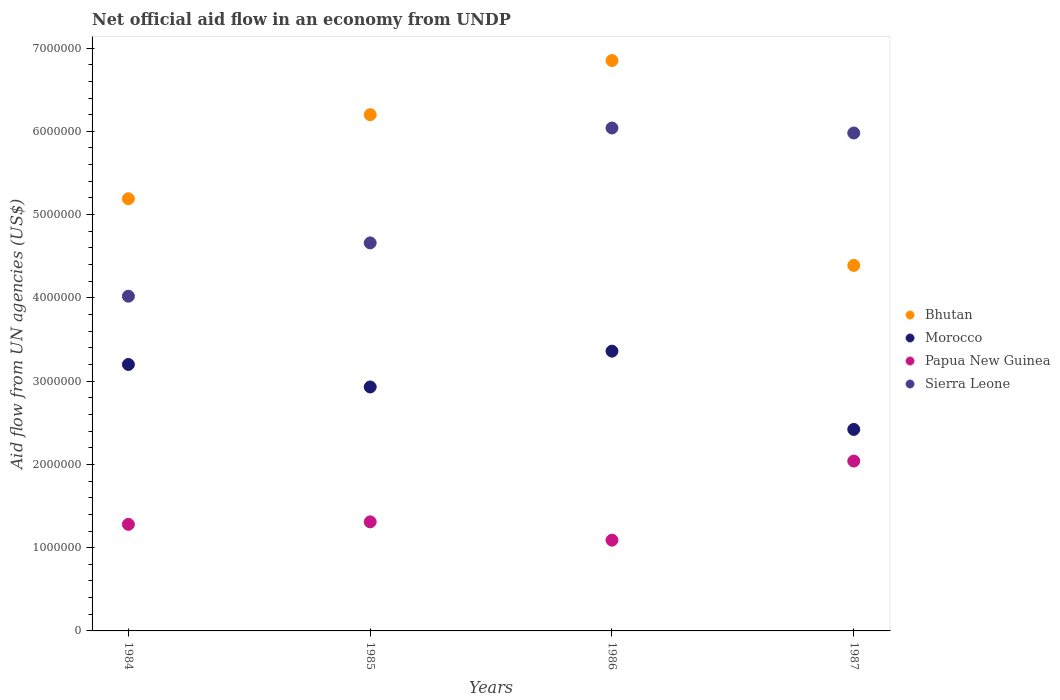Is the number of dotlines equal to the number of legend labels?
Your answer should be very brief. Yes. What is the net official aid flow in Sierra Leone in 1984?
Ensure brevity in your answer.  4.02e+06. Across all years, what is the maximum net official aid flow in Sierra Leone?
Give a very brief answer. 6.04e+06. Across all years, what is the minimum net official aid flow in Sierra Leone?
Give a very brief answer. 4.02e+06. In which year was the net official aid flow in Morocco maximum?
Your response must be concise. 1986. In which year was the net official aid flow in Papua New Guinea minimum?
Offer a terse response. 1986. What is the total net official aid flow in Sierra Leone in the graph?
Your answer should be compact. 2.07e+07. What is the difference between the net official aid flow in Papua New Guinea in 1984 and that in 1987?
Give a very brief answer. -7.60e+05. What is the difference between the net official aid flow in Papua New Guinea in 1985 and the net official aid flow in Bhutan in 1987?
Provide a short and direct response. -3.08e+06. What is the average net official aid flow in Bhutan per year?
Provide a short and direct response. 5.66e+06. In the year 1987, what is the difference between the net official aid flow in Morocco and net official aid flow in Papua New Guinea?
Keep it short and to the point. 3.80e+05. In how many years, is the net official aid flow in Bhutan greater than 1400000 US$?
Your answer should be compact. 4. What is the ratio of the net official aid flow in Morocco in 1985 to that in 1986?
Give a very brief answer. 0.87. Is the net official aid flow in Bhutan in 1984 less than that in 1987?
Make the answer very short. No. What is the difference between the highest and the lowest net official aid flow in Sierra Leone?
Ensure brevity in your answer.  2.02e+06. Is the sum of the net official aid flow in Papua New Guinea in 1985 and 1986 greater than the maximum net official aid flow in Morocco across all years?
Offer a very short reply. No. Is the net official aid flow in Morocco strictly less than the net official aid flow in Sierra Leone over the years?
Provide a succinct answer. Yes. Does the graph contain any zero values?
Offer a terse response. No. Where does the legend appear in the graph?
Provide a succinct answer. Center right. How many legend labels are there?
Offer a terse response. 4. What is the title of the graph?
Provide a succinct answer. Net official aid flow in an economy from UNDP. What is the label or title of the Y-axis?
Provide a short and direct response. Aid flow from UN agencies (US$). What is the Aid flow from UN agencies (US$) of Bhutan in 1984?
Make the answer very short. 5.19e+06. What is the Aid flow from UN agencies (US$) of Morocco in 1984?
Make the answer very short. 3.20e+06. What is the Aid flow from UN agencies (US$) of Papua New Guinea in 1984?
Your response must be concise. 1.28e+06. What is the Aid flow from UN agencies (US$) in Sierra Leone in 1984?
Your answer should be very brief. 4.02e+06. What is the Aid flow from UN agencies (US$) in Bhutan in 1985?
Offer a very short reply. 6.20e+06. What is the Aid flow from UN agencies (US$) of Morocco in 1985?
Your answer should be very brief. 2.93e+06. What is the Aid flow from UN agencies (US$) in Papua New Guinea in 1985?
Your answer should be very brief. 1.31e+06. What is the Aid flow from UN agencies (US$) in Sierra Leone in 1985?
Make the answer very short. 4.66e+06. What is the Aid flow from UN agencies (US$) in Bhutan in 1986?
Ensure brevity in your answer.  6.85e+06. What is the Aid flow from UN agencies (US$) of Morocco in 1986?
Provide a short and direct response. 3.36e+06. What is the Aid flow from UN agencies (US$) in Papua New Guinea in 1986?
Give a very brief answer. 1.09e+06. What is the Aid flow from UN agencies (US$) of Sierra Leone in 1986?
Offer a terse response. 6.04e+06. What is the Aid flow from UN agencies (US$) of Bhutan in 1987?
Offer a terse response. 4.39e+06. What is the Aid flow from UN agencies (US$) in Morocco in 1987?
Give a very brief answer. 2.42e+06. What is the Aid flow from UN agencies (US$) of Papua New Guinea in 1987?
Ensure brevity in your answer.  2.04e+06. What is the Aid flow from UN agencies (US$) in Sierra Leone in 1987?
Your response must be concise. 5.98e+06. Across all years, what is the maximum Aid flow from UN agencies (US$) in Bhutan?
Keep it short and to the point. 6.85e+06. Across all years, what is the maximum Aid flow from UN agencies (US$) of Morocco?
Offer a terse response. 3.36e+06. Across all years, what is the maximum Aid flow from UN agencies (US$) of Papua New Guinea?
Offer a very short reply. 2.04e+06. Across all years, what is the maximum Aid flow from UN agencies (US$) of Sierra Leone?
Provide a short and direct response. 6.04e+06. Across all years, what is the minimum Aid flow from UN agencies (US$) in Bhutan?
Offer a very short reply. 4.39e+06. Across all years, what is the minimum Aid flow from UN agencies (US$) of Morocco?
Provide a short and direct response. 2.42e+06. Across all years, what is the minimum Aid flow from UN agencies (US$) of Papua New Guinea?
Offer a very short reply. 1.09e+06. Across all years, what is the minimum Aid flow from UN agencies (US$) in Sierra Leone?
Provide a succinct answer. 4.02e+06. What is the total Aid flow from UN agencies (US$) of Bhutan in the graph?
Give a very brief answer. 2.26e+07. What is the total Aid flow from UN agencies (US$) of Morocco in the graph?
Ensure brevity in your answer.  1.19e+07. What is the total Aid flow from UN agencies (US$) of Papua New Guinea in the graph?
Your answer should be compact. 5.72e+06. What is the total Aid flow from UN agencies (US$) in Sierra Leone in the graph?
Your answer should be very brief. 2.07e+07. What is the difference between the Aid flow from UN agencies (US$) of Bhutan in 1984 and that in 1985?
Your response must be concise. -1.01e+06. What is the difference between the Aid flow from UN agencies (US$) of Morocco in 1984 and that in 1985?
Make the answer very short. 2.70e+05. What is the difference between the Aid flow from UN agencies (US$) in Sierra Leone in 1984 and that in 1985?
Keep it short and to the point. -6.40e+05. What is the difference between the Aid flow from UN agencies (US$) in Bhutan in 1984 and that in 1986?
Make the answer very short. -1.66e+06. What is the difference between the Aid flow from UN agencies (US$) in Sierra Leone in 1984 and that in 1986?
Make the answer very short. -2.02e+06. What is the difference between the Aid flow from UN agencies (US$) in Morocco in 1984 and that in 1987?
Your answer should be compact. 7.80e+05. What is the difference between the Aid flow from UN agencies (US$) of Papua New Guinea in 1984 and that in 1987?
Offer a terse response. -7.60e+05. What is the difference between the Aid flow from UN agencies (US$) in Sierra Leone in 1984 and that in 1987?
Offer a very short reply. -1.96e+06. What is the difference between the Aid flow from UN agencies (US$) in Bhutan in 1985 and that in 1986?
Offer a very short reply. -6.50e+05. What is the difference between the Aid flow from UN agencies (US$) of Morocco in 1985 and that in 1986?
Provide a short and direct response. -4.30e+05. What is the difference between the Aid flow from UN agencies (US$) of Papua New Guinea in 1985 and that in 1986?
Your answer should be compact. 2.20e+05. What is the difference between the Aid flow from UN agencies (US$) in Sierra Leone in 1985 and that in 1986?
Your answer should be compact. -1.38e+06. What is the difference between the Aid flow from UN agencies (US$) of Bhutan in 1985 and that in 1987?
Keep it short and to the point. 1.81e+06. What is the difference between the Aid flow from UN agencies (US$) in Morocco in 1985 and that in 1987?
Make the answer very short. 5.10e+05. What is the difference between the Aid flow from UN agencies (US$) in Papua New Guinea in 1985 and that in 1987?
Your answer should be very brief. -7.30e+05. What is the difference between the Aid flow from UN agencies (US$) in Sierra Leone in 1985 and that in 1987?
Ensure brevity in your answer.  -1.32e+06. What is the difference between the Aid flow from UN agencies (US$) in Bhutan in 1986 and that in 1987?
Make the answer very short. 2.46e+06. What is the difference between the Aid flow from UN agencies (US$) in Morocco in 1986 and that in 1987?
Provide a short and direct response. 9.40e+05. What is the difference between the Aid flow from UN agencies (US$) in Papua New Guinea in 1986 and that in 1987?
Your response must be concise. -9.50e+05. What is the difference between the Aid flow from UN agencies (US$) of Bhutan in 1984 and the Aid flow from UN agencies (US$) of Morocco in 1985?
Your response must be concise. 2.26e+06. What is the difference between the Aid flow from UN agencies (US$) of Bhutan in 1984 and the Aid flow from UN agencies (US$) of Papua New Guinea in 1985?
Provide a short and direct response. 3.88e+06. What is the difference between the Aid flow from UN agencies (US$) of Bhutan in 1984 and the Aid flow from UN agencies (US$) of Sierra Leone in 1985?
Offer a terse response. 5.30e+05. What is the difference between the Aid flow from UN agencies (US$) of Morocco in 1984 and the Aid flow from UN agencies (US$) of Papua New Guinea in 1985?
Your answer should be compact. 1.89e+06. What is the difference between the Aid flow from UN agencies (US$) in Morocco in 1984 and the Aid flow from UN agencies (US$) in Sierra Leone in 1985?
Provide a short and direct response. -1.46e+06. What is the difference between the Aid flow from UN agencies (US$) of Papua New Guinea in 1984 and the Aid flow from UN agencies (US$) of Sierra Leone in 1985?
Provide a short and direct response. -3.38e+06. What is the difference between the Aid flow from UN agencies (US$) in Bhutan in 1984 and the Aid flow from UN agencies (US$) in Morocco in 1986?
Provide a short and direct response. 1.83e+06. What is the difference between the Aid flow from UN agencies (US$) of Bhutan in 1984 and the Aid flow from UN agencies (US$) of Papua New Guinea in 1986?
Offer a terse response. 4.10e+06. What is the difference between the Aid flow from UN agencies (US$) in Bhutan in 1984 and the Aid flow from UN agencies (US$) in Sierra Leone in 1986?
Offer a very short reply. -8.50e+05. What is the difference between the Aid flow from UN agencies (US$) in Morocco in 1984 and the Aid flow from UN agencies (US$) in Papua New Guinea in 1986?
Ensure brevity in your answer.  2.11e+06. What is the difference between the Aid flow from UN agencies (US$) of Morocco in 1984 and the Aid flow from UN agencies (US$) of Sierra Leone in 1986?
Provide a succinct answer. -2.84e+06. What is the difference between the Aid flow from UN agencies (US$) in Papua New Guinea in 1984 and the Aid flow from UN agencies (US$) in Sierra Leone in 1986?
Provide a succinct answer. -4.76e+06. What is the difference between the Aid flow from UN agencies (US$) in Bhutan in 1984 and the Aid flow from UN agencies (US$) in Morocco in 1987?
Keep it short and to the point. 2.77e+06. What is the difference between the Aid flow from UN agencies (US$) in Bhutan in 1984 and the Aid flow from UN agencies (US$) in Papua New Guinea in 1987?
Provide a short and direct response. 3.15e+06. What is the difference between the Aid flow from UN agencies (US$) in Bhutan in 1984 and the Aid flow from UN agencies (US$) in Sierra Leone in 1987?
Your answer should be very brief. -7.90e+05. What is the difference between the Aid flow from UN agencies (US$) in Morocco in 1984 and the Aid flow from UN agencies (US$) in Papua New Guinea in 1987?
Your response must be concise. 1.16e+06. What is the difference between the Aid flow from UN agencies (US$) in Morocco in 1984 and the Aid flow from UN agencies (US$) in Sierra Leone in 1987?
Offer a very short reply. -2.78e+06. What is the difference between the Aid flow from UN agencies (US$) in Papua New Guinea in 1984 and the Aid flow from UN agencies (US$) in Sierra Leone in 1987?
Offer a terse response. -4.70e+06. What is the difference between the Aid flow from UN agencies (US$) in Bhutan in 1985 and the Aid flow from UN agencies (US$) in Morocco in 1986?
Keep it short and to the point. 2.84e+06. What is the difference between the Aid flow from UN agencies (US$) of Bhutan in 1985 and the Aid flow from UN agencies (US$) of Papua New Guinea in 1986?
Make the answer very short. 5.11e+06. What is the difference between the Aid flow from UN agencies (US$) in Morocco in 1985 and the Aid flow from UN agencies (US$) in Papua New Guinea in 1986?
Keep it short and to the point. 1.84e+06. What is the difference between the Aid flow from UN agencies (US$) in Morocco in 1985 and the Aid flow from UN agencies (US$) in Sierra Leone in 1986?
Give a very brief answer. -3.11e+06. What is the difference between the Aid flow from UN agencies (US$) of Papua New Guinea in 1985 and the Aid flow from UN agencies (US$) of Sierra Leone in 1986?
Your response must be concise. -4.73e+06. What is the difference between the Aid flow from UN agencies (US$) in Bhutan in 1985 and the Aid flow from UN agencies (US$) in Morocco in 1987?
Provide a short and direct response. 3.78e+06. What is the difference between the Aid flow from UN agencies (US$) in Bhutan in 1985 and the Aid flow from UN agencies (US$) in Papua New Guinea in 1987?
Keep it short and to the point. 4.16e+06. What is the difference between the Aid flow from UN agencies (US$) in Bhutan in 1985 and the Aid flow from UN agencies (US$) in Sierra Leone in 1987?
Your answer should be compact. 2.20e+05. What is the difference between the Aid flow from UN agencies (US$) of Morocco in 1985 and the Aid flow from UN agencies (US$) of Papua New Guinea in 1987?
Your response must be concise. 8.90e+05. What is the difference between the Aid flow from UN agencies (US$) of Morocco in 1985 and the Aid flow from UN agencies (US$) of Sierra Leone in 1987?
Provide a short and direct response. -3.05e+06. What is the difference between the Aid flow from UN agencies (US$) in Papua New Guinea in 1985 and the Aid flow from UN agencies (US$) in Sierra Leone in 1987?
Offer a terse response. -4.67e+06. What is the difference between the Aid flow from UN agencies (US$) in Bhutan in 1986 and the Aid flow from UN agencies (US$) in Morocco in 1987?
Provide a succinct answer. 4.43e+06. What is the difference between the Aid flow from UN agencies (US$) of Bhutan in 1986 and the Aid flow from UN agencies (US$) of Papua New Guinea in 1987?
Your response must be concise. 4.81e+06. What is the difference between the Aid flow from UN agencies (US$) in Bhutan in 1986 and the Aid flow from UN agencies (US$) in Sierra Leone in 1987?
Your answer should be compact. 8.70e+05. What is the difference between the Aid flow from UN agencies (US$) in Morocco in 1986 and the Aid flow from UN agencies (US$) in Papua New Guinea in 1987?
Provide a short and direct response. 1.32e+06. What is the difference between the Aid flow from UN agencies (US$) in Morocco in 1986 and the Aid flow from UN agencies (US$) in Sierra Leone in 1987?
Your response must be concise. -2.62e+06. What is the difference between the Aid flow from UN agencies (US$) in Papua New Guinea in 1986 and the Aid flow from UN agencies (US$) in Sierra Leone in 1987?
Ensure brevity in your answer.  -4.89e+06. What is the average Aid flow from UN agencies (US$) in Bhutan per year?
Provide a succinct answer. 5.66e+06. What is the average Aid flow from UN agencies (US$) in Morocco per year?
Ensure brevity in your answer.  2.98e+06. What is the average Aid flow from UN agencies (US$) in Papua New Guinea per year?
Provide a succinct answer. 1.43e+06. What is the average Aid flow from UN agencies (US$) in Sierra Leone per year?
Ensure brevity in your answer.  5.18e+06. In the year 1984, what is the difference between the Aid flow from UN agencies (US$) in Bhutan and Aid flow from UN agencies (US$) in Morocco?
Provide a short and direct response. 1.99e+06. In the year 1984, what is the difference between the Aid flow from UN agencies (US$) of Bhutan and Aid flow from UN agencies (US$) of Papua New Guinea?
Make the answer very short. 3.91e+06. In the year 1984, what is the difference between the Aid flow from UN agencies (US$) of Bhutan and Aid flow from UN agencies (US$) of Sierra Leone?
Ensure brevity in your answer.  1.17e+06. In the year 1984, what is the difference between the Aid flow from UN agencies (US$) of Morocco and Aid flow from UN agencies (US$) of Papua New Guinea?
Your answer should be compact. 1.92e+06. In the year 1984, what is the difference between the Aid flow from UN agencies (US$) in Morocco and Aid flow from UN agencies (US$) in Sierra Leone?
Provide a short and direct response. -8.20e+05. In the year 1984, what is the difference between the Aid flow from UN agencies (US$) of Papua New Guinea and Aid flow from UN agencies (US$) of Sierra Leone?
Keep it short and to the point. -2.74e+06. In the year 1985, what is the difference between the Aid flow from UN agencies (US$) in Bhutan and Aid flow from UN agencies (US$) in Morocco?
Your answer should be very brief. 3.27e+06. In the year 1985, what is the difference between the Aid flow from UN agencies (US$) in Bhutan and Aid flow from UN agencies (US$) in Papua New Guinea?
Keep it short and to the point. 4.89e+06. In the year 1985, what is the difference between the Aid flow from UN agencies (US$) in Bhutan and Aid flow from UN agencies (US$) in Sierra Leone?
Provide a short and direct response. 1.54e+06. In the year 1985, what is the difference between the Aid flow from UN agencies (US$) in Morocco and Aid flow from UN agencies (US$) in Papua New Guinea?
Offer a very short reply. 1.62e+06. In the year 1985, what is the difference between the Aid flow from UN agencies (US$) in Morocco and Aid flow from UN agencies (US$) in Sierra Leone?
Provide a succinct answer. -1.73e+06. In the year 1985, what is the difference between the Aid flow from UN agencies (US$) in Papua New Guinea and Aid flow from UN agencies (US$) in Sierra Leone?
Your answer should be compact. -3.35e+06. In the year 1986, what is the difference between the Aid flow from UN agencies (US$) in Bhutan and Aid flow from UN agencies (US$) in Morocco?
Keep it short and to the point. 3.49e+06. In the year 1986, what is the difference between the Aid flow from UN agencies (US$) of Bhutan and Aid flow from UN agencies (US$) of Papua New Guinea?
Offer a terse response. 5.76e+06. In the year 1986, what is the difference between the Aid flow from UN agencies (US$) of Bhutan and Aid flow from UN agencies (US$) of Sierra Leone?
Offer a very short reply. 8.10e+05. In the year 1986, what is the difference between the Aid flow from UN agencies (US$) in Morocco and Aid flow from UN agencies (US$) in Papua New Guinea?
Offer a very short reply. 2.27e+06. In the year 1986, what is the difference between the Aid flow from UN agencies (US$) of Morocco and Aid flow from UN agencies (US$) of Sierra Leone?
Provide a short and direct response. -2.68e+06. In the year 1986, what is the difference between the Aid flow from UN agencies (US$) in Papua New Guinea and Aid flow from UN agencies (US$) in Sierra Leone?
Provide a succinct answer. -4.95e+06. In the year 1987, what is the difference between the Aid flow from UN agencies (US$) of Bhutan and Aid flow from UN agencies (US$) of Morocco?
Make the answer very short. 1.97e+06. In the year 1987, what is the difference between the Aid flow from UN agencies (US$) in Bhutan and Aid flow from UN agencies (US$) in Papua New Guinea?
Offer a very short reply. 2.35e+06. In the year 1987, what is the difference between the Aid flow from UN agencies (US$) in Bhutan and Aid flow from UN agencies (US$) in Sierra Leone?
Offer a very short reply. -1.59e+06. In the year 1987, what is the difference between the Aid flow from UN agencies (US$) of Morocco and Aid flow from UN agencies (US$) of Sierra Leone?
Make the answer very short. -3.56e+06. In the year 1987, what is the difference between the Aid flow from UN agencies (US$) in Papua New Guinea and Aid flow from UN agencies (US$) in Sierra Leone?
Make the answer very short. -3.94e+06. What is the ratio of the Aid flow from UN agencies (US$) of Bhutan in 1984 to that in 1985?
Your response must be concise. 0.84. What is the ratio of the Aid flow from UN agencies (US$) in Morocco in 1984 to that in 1985?
Offer a terse response. 1.09. What is the ratio of the Aid flow from UN agencies (US$) of Papua New Guinea in 1984 to that in 1985?
Your answer should be compact. 0.98. What is the ratio of the Aid flow from UN agencies (US$) of Sierra Leone in 1984 to that in 1985?
Keep it short and to the point. 0.86. What is the ratio of the Aid flow from UN agencies (US$) of Bhutan in 1984 to that in 1986?
Your answer should be very brief. 0.76. What is the ratio of the Aid flow from UN agencies (US$) of Morocco in 1984 to that in 1986?
Keep it short and to the point. 0.95. What is the ratio of the Aid flow from UN agencies (US$) of Papua New Guinea in 1984 to that in 1986?
Offer a very short reply. 1.17. What is the ratio of the Aid flow from UN agencies (US$) of Sierra Leone in 1984 to that in 1986?
Keep it short and to the point. 0.67. What is the ratio of the Aid flow from UN agencies (US$) of Bhutan in 1984 to that in 1987?
Make the answer very short. 1.18. What is the ratio of the Aid flow from UN agencies (US$) of Morocco in 1984 to that in 1987?
Provide a short and direct response. 1.32. What is the ratio of the Aid flow from UN agencies (US$) of Papua New Guinea in 1984 to that in 1987?
Offer a very short reply. 0.63. What is the ratio of the Aid flow from UN agencies (US$) in Sierra Leone in 1984 to that in 1987?
Keep it short and to the point. 0.67. What is the ratio of the Aid flow from UN agencies (US$) of Bhutan in 1985 to that in 1986?
Your response must be concise. 0.91. What is the ratio of the Aid flow from UN agencies (US$) of Morocco in 1985 to that in 1986?
Your response must be concise. 0.87. What is the ratio of the Aid flow from UN agencies (US$) in Papua New Guinea in 1985 to that in 1986?
Your answer should be very brief. 1.2. What is the ratio of the Aid flow from UN agencies (US$) of Sierra Leone in 1985 to that in 1986?
Give a very brief answer. 0.77. What is the ratio of the Aid flow from UN agencies (US$) in Bhutan in 1985 to that in 1987?
Keep it short and to the point. 1.41. What is the ratio of the Aid flow from UN agencies (US$) in Morocco in 1985 to that in 1987?
Your response must be concise. 1.21. What is the ratio of the Aid flow from UN agencies (US$) in Papua New Guinea in 1985 to that in 1987?
Your response must be concise. 0.64. What is the ratio of the Aid flow from UN agencies (US$) in Sierra Leone in 1985 to that in 1987?
Give a very brief answer. 0.78. What is the ratio of the Aid flow from UN agencies (US$) in Bhutan in 1986 to that in 1987?
Offer a terse response. 1.56. What is the ratio of the Aid flow from UN agencies (US$) of Morocco in 1986 to that in 1987?
Your response must be concise. 1.39. What is the ratio of the Aid flow from UN agencies (US$) in Papua New Guinea in 1986 to that in 1987?
Offer a very short reply. 0.53. What is the difference between the highest and the second highest Aid flow from UN agencies (US$) in Bhutan?
Make the answer very short. 6.50e+05. What is the difference between the highest and the second highest Aid flow from UN agencies (US$) of Papua New Guinea?
Provide a succinct answer. 7.30e+05. What is the difference between the highest and the second highest Aid flow from UN agencies (US$) of Sierra Leone?
Make the answer very short. 6.00e+04. What is the difference between the highest and the lowest Aid flow from UN agencies (US$) in Bhutan?
Give a very brief answer. 2.46e+06. What is the difference between the highest and the lowest Aid flow from UN agencies (US$) of Morocco?
Your response must be concise. 9.40e+05. What is the difference between the highest and the lowest Aid flow from UN agencies (US$) of Papua New Guinea?
Your response must be concise. 9.50e+05. What is the difference between the highest and the lowest Aid flow from UN agencies (US$) of Sierra Leone?
Ensure brevity in your answer.  2.02e+06. 